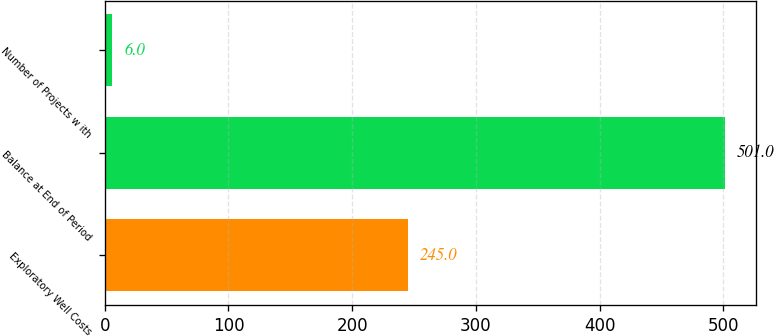Convert chart to OTSL. <chart><loc_0><loc_0><loc_500><loc_500><bar_chart><fcel>Exploratory Well Costs<fcel>Balance at End of Period<fcel>Number of Projects w ith<nl><fcel>245<fcel>501<fcel>6<nl></chart> 